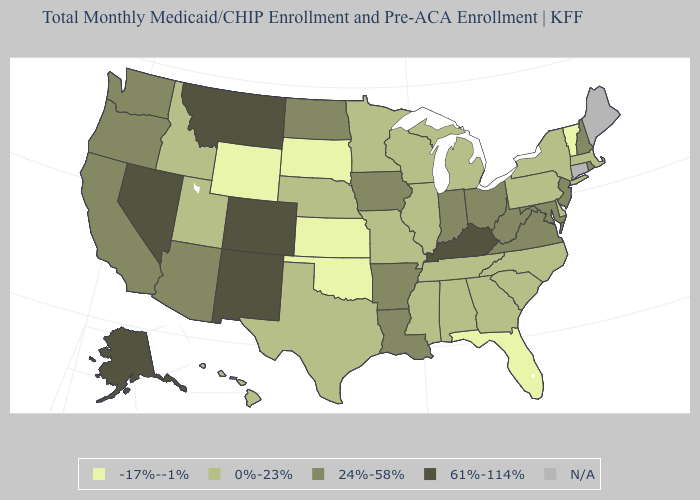Which states hav the highest value in the West?
Write a very short answer. Alaska, Colorado, Montana, Nevada, New Mexico. Among the states that border Vermont , which have the lowest value?
Be succinct. Massachusetts, New York. What is the value of Oregon?
Short answer required. 24%-58%. Name the states that have a value in the range -17%--1%?
Write a very short answer. Florida, Kansas, Oklahoma, South Dakota, Vermont, Wyoming. What is the value of Vermont?
Give a very brief answer. -17%--1%. Which states have the lowest value in the USA?
Quick response, please. Florida, Kansas, Oklahoma, South Dakota, Vermont, Wyoming. Which states have the highest value in the USA?
Short answer required. Alaska, Colorado, Kentucky, Montana, Nevada, New Mexico. Name the states that have a value in the range -17%--1%?
Concise answer only. Florida, Kansas, Oklahoma, South Dakota, Vermont, Wyoming. What is the highest value in states that border California?
Concise answer only. 61%-114%. What is the value of Minnesota?
Be succinct. 0%-23%. What is the value of New Mexico?
Concise answer only. 61%-114%. What is the value of Kansas?
Keep it brief. -17%--1%. Does the first symbol in the legend represent the smallest category?
Be succinct. Yes. Name the states that have a value in the range 0%-23%?
Short answer required. Alabama, Delaware, Georgia, Hawaii, Idaho, Illinois, Massachusetts, Michigan, Minnesota, Mississippi, Missouri, Nebraska, New York, North Carolina, Pennsylvania, South Carolina, Tennessee, Texas, Utah, Wisconsin. 